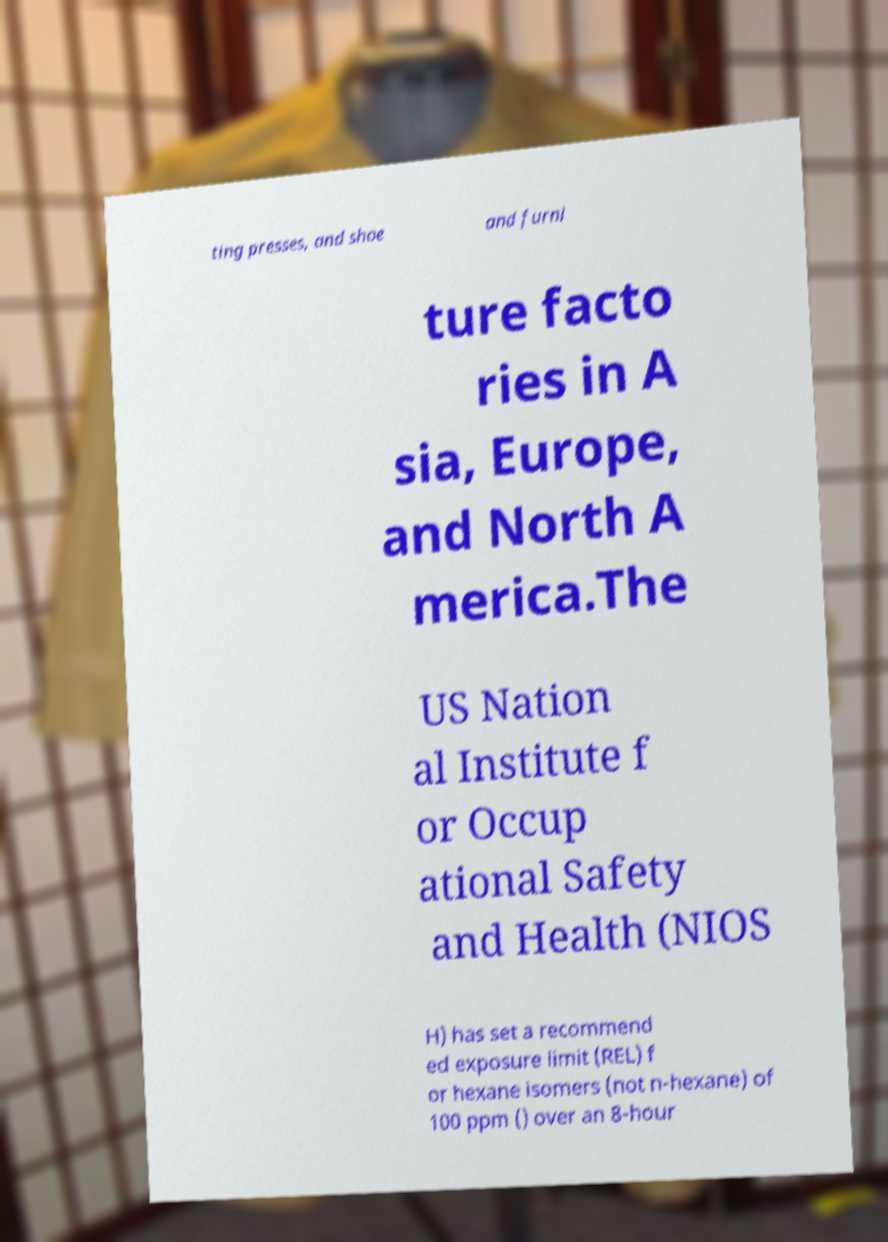Can you accurately transcribe the text from the provided image for me? ting presses, and shoe and furni ture facto ries in A sia, Europe, and North A merica.The US Nation al Institute f or Occup ational Safety and Health (NIOS H) has set a recommend ed exposure limit (REL) f or hexane isomers (not n-hexane) of 100 ppm () over an 8-hour 